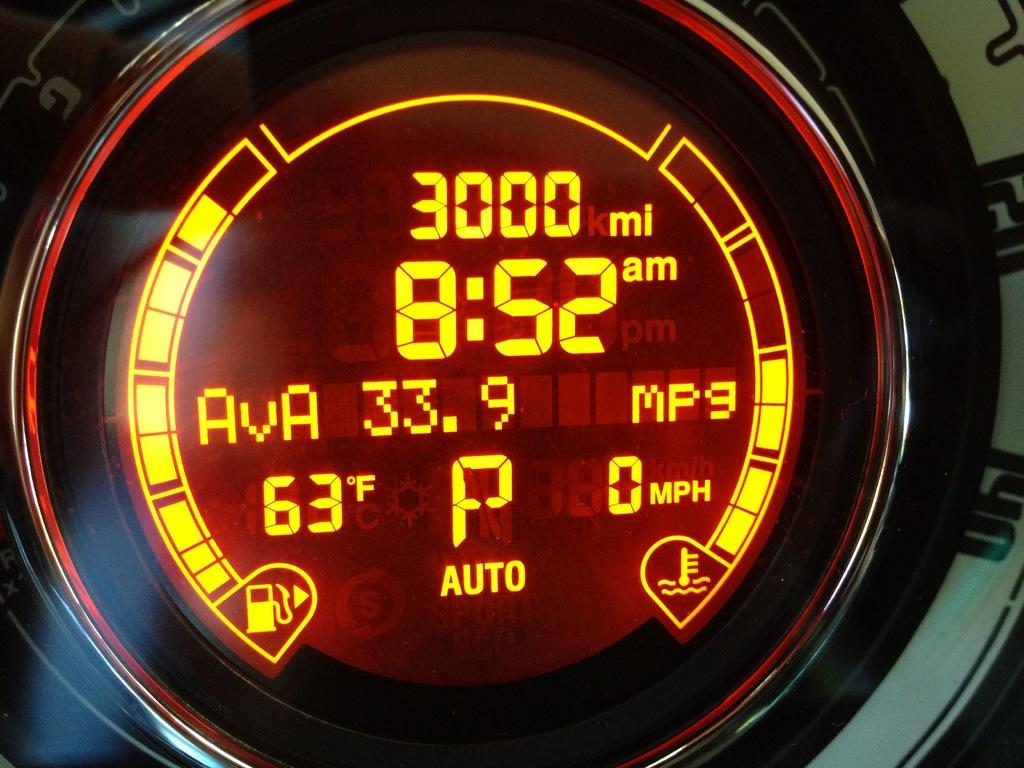<image>
Present a compact description of the photo's key features. The time is displayed as 8.52 am in neon orange. 